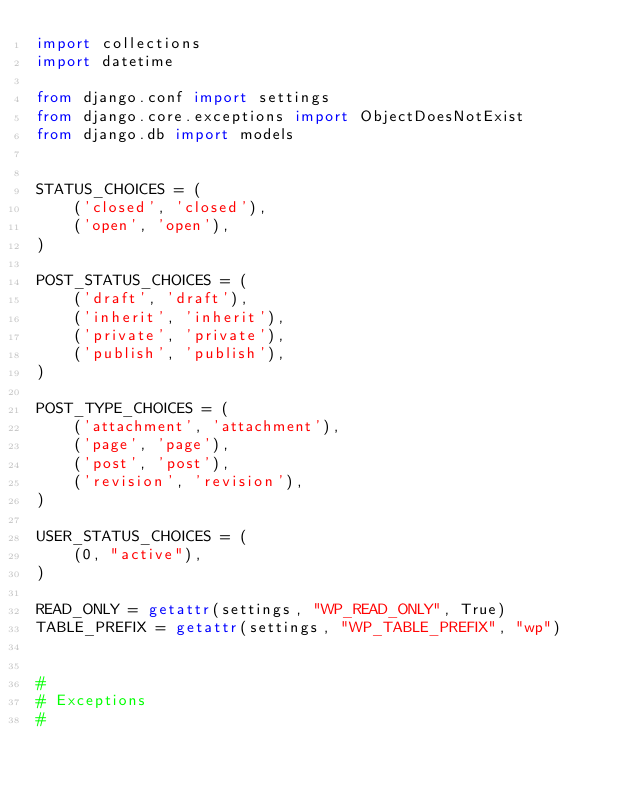Convert code to text. <code><loc_0><loc_0><loc_500><loc_500><_Python_>import collections
import datetime

from django.conf import settings
from django.core.exceptions import ObjectDoesNotExist
from django.db import models


STATUS_CHOICES = (
    ('closed', 'closed'),
    ('open', 'open'),
)

POST_STATUS_CHOICES = (
    ('draft', 'draft'),
    ('inherit', 'inherit'),
    ('private', 'private'),
    ('publish', 'publish'),
)

POST_TYPE_CHOICES = (
    ('attachment', 'attachment'),
    ('page', 'page'),
    ('post', 'post'),
    ('revision', 'revision'),
)

USER_STATUS_CHOICES = (
    (0, "active"),
)

READ_ONLY = getattr(settings, "WP_READ_ONLY", True)
TABLE_PREFIX = getattr(settings, "WP_TABLE_PREFIX", "wp")


#
# Exceptions
#
</code> 